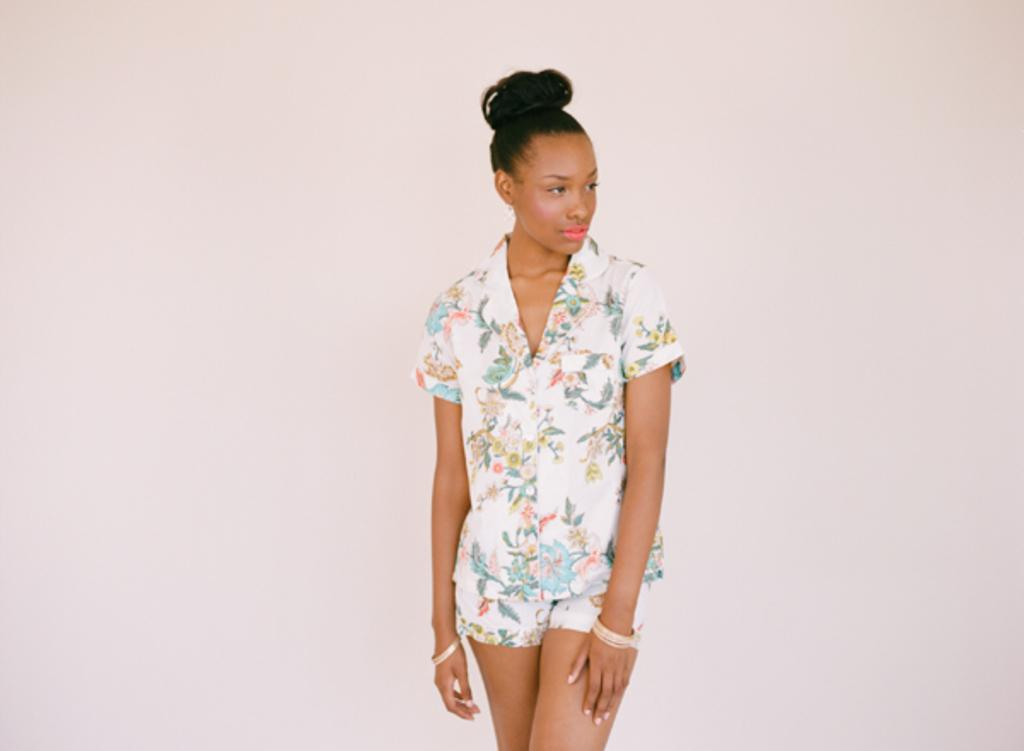Who is the main subject in the image? There is a woman in the image. What is the woman doing in the image? The woman is standing and posing for a photo. Where can the beds be found in the image? There are no beds present in the image. What type of market is visible in the image? There is no market visible in the image; it features a woman standing and posing for a photo. 